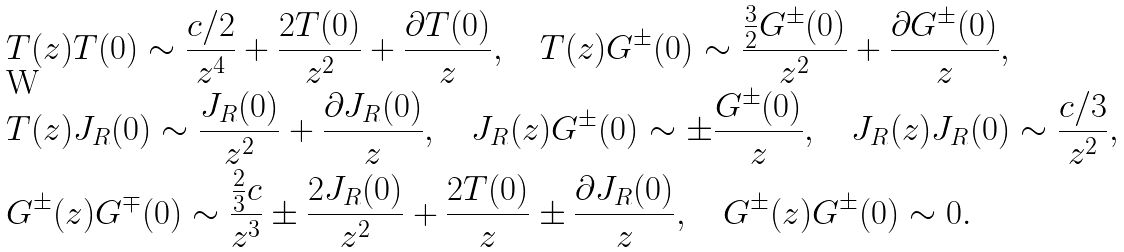<formula> <loc_0><loc_0><loc_500><loc_500>& T ( z ) T ( 0 ) \sim \frac { c / 2 } { z ^ { 4 } } + \frac { 2 T ( 0 ) } { z ^ { 2 } } + \frac { \partial T ( 0 ) } { z } , \quad T ( z ) G ^ { \pm } ( 0 ) \sim \frac { \frac { 3 } { 2 } G ^ { \pm } ( 0 ) } { z ^ { 2 } } + \frac { \partial G ^ { \pm } ( 0 ) } { z } , \\ & T ( z ) J _ { R } ( 0 ) \sim \frac { J _ { R } ( 0 ) } { z ^ { 2 } } + \frac { \partial J _ { R } ( 0 ) } { z } , \quad J _ { R } ( z ) G ^ { \pm } ( 0 ) \sim \pm \frac { G ^ { \pm } ( 0 ) } { z } , \quad J _ { R } ( z ) J _ { R } ( 0 ) \sim \frac { c / 3 } { z ^ { 2 } } , \\ & G ^ { \pm } ( z ) G ^ { \mp } ( 0 ) \sim \frac { \frac { 2 } { 3 } c } { z ^ { 3 } } \pm \frac { 2 J _ { R } ( 0 ) } { z ^ { 2 } } + \frac { 2 T ( 0 ) } { z } \pm \frac { \partial J _ { R } ( 0 ) } { z } , \quad G ^ { \pm } ( z ) G ^ { \pm } ( 0 ) \sim 0 .</formula> 